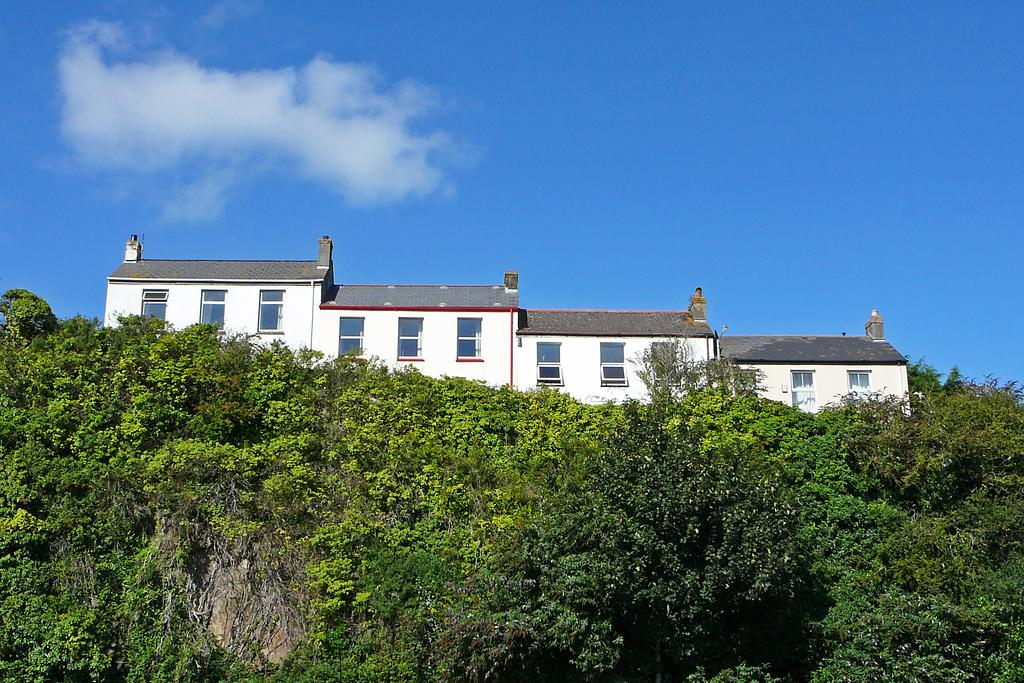What type of structure is present in the image? There is a building in the image. Can you describe the building's features? The building has multiple windows and a roof. What is located in the foreground of the image? There is a group of trees in the foreground of the image. What can be seen in the background of the image? The sky is visible in the background of the image. How would you describe the sky's condition? The sky appears to be cloudy. What type of noise can be heard coming from the hands in the image? There are no hands present in the image, so it's not possible to determine what, if any, noise might be heard. --- Facts: 1. There is a person sitting on a chair in the image. 2. The person is holding a book. 3. The book has a blue cover. 4. There is a table next to the chair. 5. The table has a lamp on it. Absurd Topics: fish, ocean, waves Conversation: What is the person in the image doing? The person is sitting on a chair in the image. What is the person holding? The person is holding a book. Can you describe the book's appearance? The book has a blue cover. What is located next to the chair? There is a table next to the chair. What is on the table? The table has a lamp on it. Reasoning: Let's think step by step in order to produce the conversation. We start by identifying the main subject of the image, which is the person sitting on a chair. Then, we describe what the person is holding, which is a book. Next, we observe the book's appearance, noting its blue cover. Finally, we describe the table and its contents, which include a lamp. Absurd Question/Answer: How many fish can be seen swimming in the waves in the image? There are no fish or waves present in the image; it features a person sitting on a chair holding a book. 